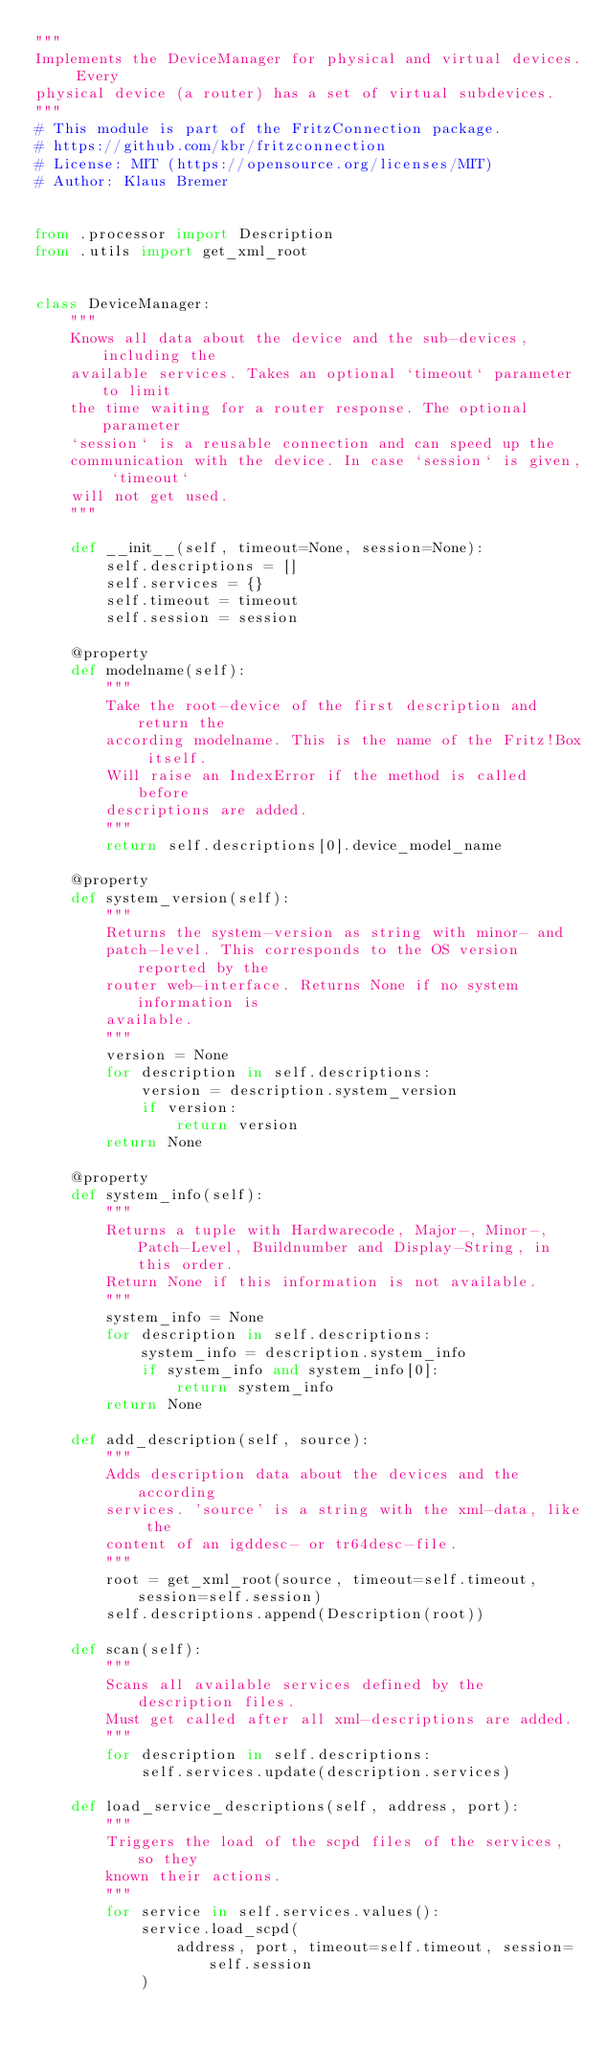<code> <loc_0><loc_0><loc_500><loc_500><_Python_>"""
Implements the DeviceManager for physical and virtual devices. Every
physical device (a router) has a set of virtual subdevices.
"""
# This module is part of the FritzConnection package.
# https://github.com/kbr/fritzconnection
# License: MIT (https://opensource.org/licenses/MIT)
# Author: Klaus Bremer


from .processor import Description
from .utils import get_xml_root


class DeviceManager:
    """
    Knows all data about the device and the sub-devices, including the
    available services. Takes an optional `timeout` parameter to limit
    the time waiting for a router response. The optional parameter
    `session` is a reusable connection and can speed up the
    communication with the device. In case `session` is given, `timeout`
    will not get used.
    """

    def __init__(self, timeout=None, session=None):
        self.descriptions = []
        self.services = {}
        self.timeout = timeout
        self.session = session

    @property
    def modelname(self):
        """
        Take the root-device of the first description and return the
        according modelname. This is the name of the Fritz!Box itself.
        Will raise an IndexError if the method is called before
        descriptions are added.
        """
        return self.descriptions[0].device_model_name

    @property
    def system_version(self):
        """
        Returns the system-version as string with minor- and
        patch-level. This corresponds to the OS version reported by the
        router web-interface. Returns None if no system information is
        available.
        """
        version = None
        for description in self.descriptions:
            version = description.system_version
            if version:
                return version
        return None

    @property
    def system_info(self):
        """
        Returns a tuple with Hardwarecode, Major-, Minor-, Patch-Level, Buildnumber and Display-String, in this order.
        Return None if this information is not available.
        """
        system_info = None
        for description in self.descriptions:
            system_info = description.system_info
            if system_info and system_info[0]:
                return system_info
        return None

    def add_description(self, source):
        """
        Adds description data about the devices and the according
        services. 'source' is a string with the xml-data, like the
        content of an igddesc- or tr64desc-file.
        """
        root = get_xml_root(source, timeout=self.timeout, session=self.session)
        self.descriptions.append(Description(root))

    def scan(self):
        """
        Scans all available services defined by the description files.
        Must get called after all xml-descriptions are added.
        """
        for description in self.descriptions:
            self.services.update(description.services)

    def load_service_descriptions(self, address, port):
        """
        Triggers the load of the scpd files of the services, so they
        known their actions.
        """
        for service in self.services.values():
            service.load_scpd(
                address, port, timeout=self.timeout, session=self.session
            )

</code> 